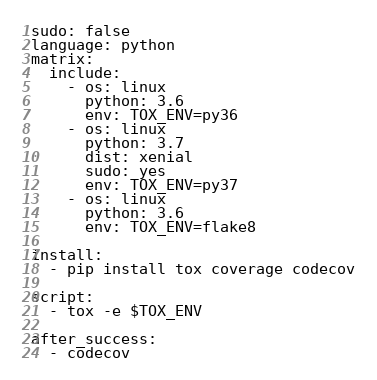<code> <loc_0><loc_0><loc_500><loc_500><_YAML_>sudo: false
language: python
matrix:
  include:
    - os: linux
      python: 3.6
      env: TOX_ENV=py36
    - os: linux
      python: 3.7
      dist: xenial
      sudo: yes
      env: TOX_ENV=py37
    - os: linux
      python: 3.6
      env: TOX_ENV=flake8

install:
  - pip install tox coverage codecov

script:
  - tox -e $TOX_ENV

after_success:
  - codecov
</code> 